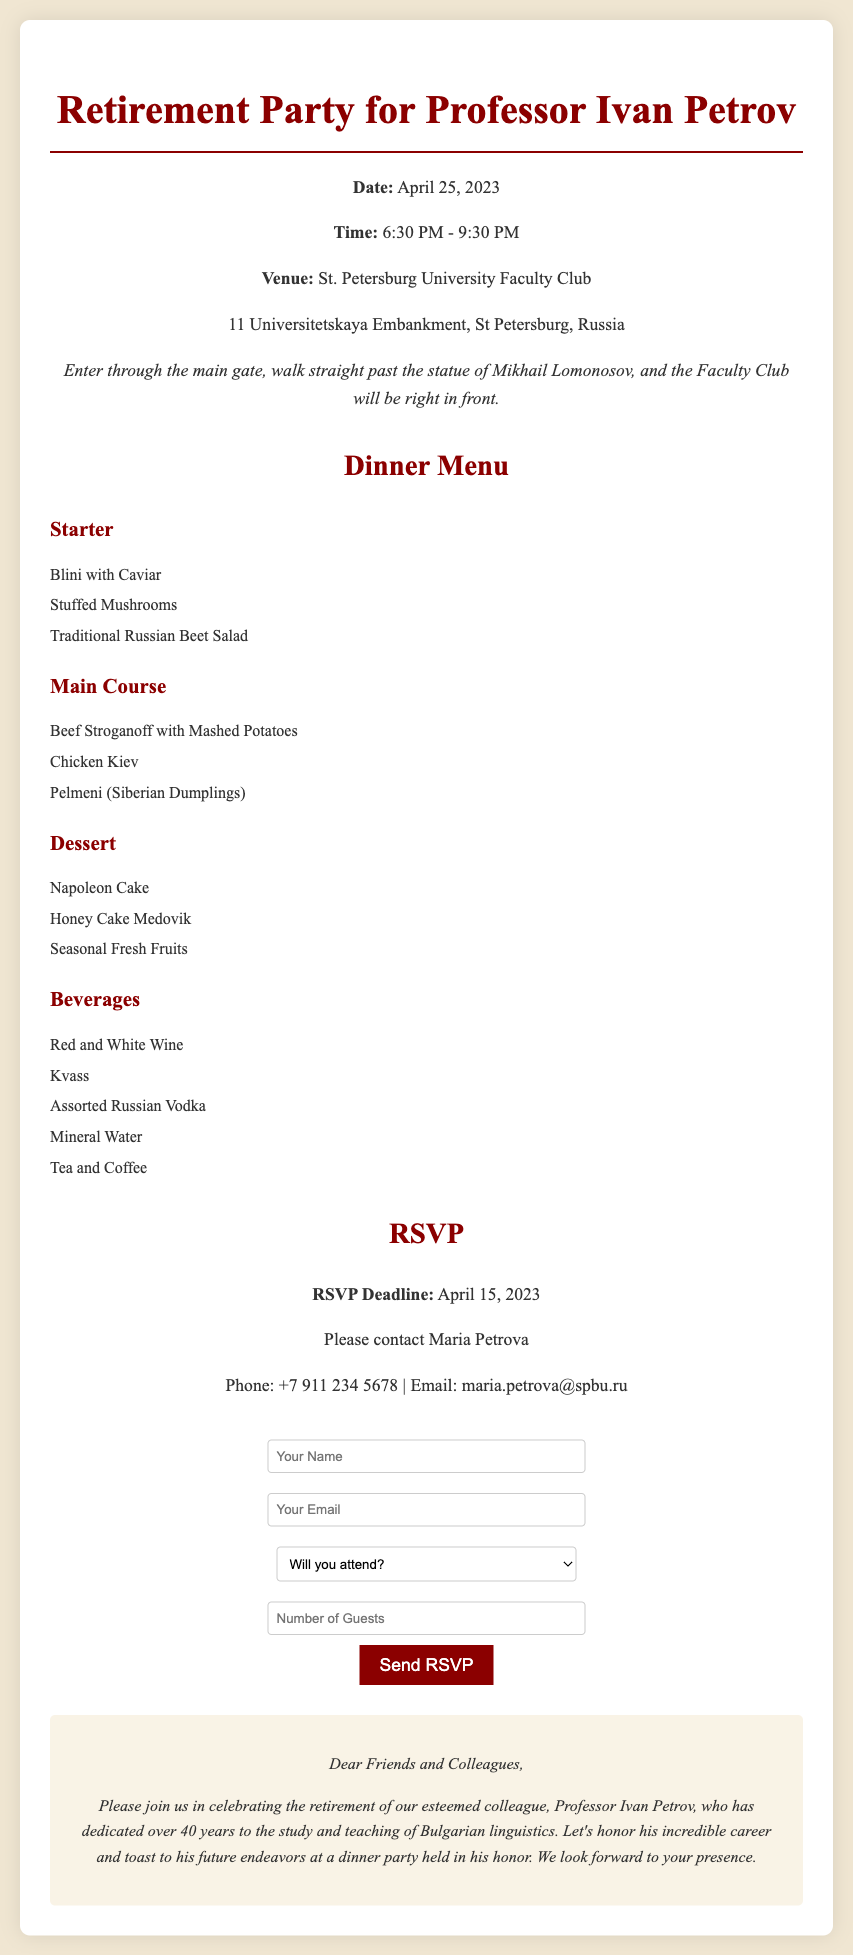What is the date of the retirement party? The date of the retirement party is specified in the document.
Answer: April 25, 2023 What is the venue for the event? The venue for the retirement party is mentioned directly in the document.
Answer: St. Petersburg University Faculty Club What time does the party start? The starting time is clearly stated in the event details.
Answer: 6:30 PM Who should guests contact for RSVP? The document provides the name of the contact person for RSVP.
Answer: Maria Petrova What is the RSVP deadline? The deadline for RSVP is provided in the RSVP section.
Answer: April 15, 2023 What dish is listed under the Main Course? The document includes a variety of dishes in the menu section.
Answer: Beef Stroganoff with Mashed Potatoes How many guests can you indicate in the RSVP form? The RSVP form indicates a limit on the number of guests.
Answer: 2 What type of dessert is offered? The dessert selection is outlined in the menu section of the document.
Answer: Napoleon Cake How is the venue accessed? Directions to the venue are provided in the event details.
Answer: Enter through the main gate, walk straight past the statue of Mikhail Lomonosov 